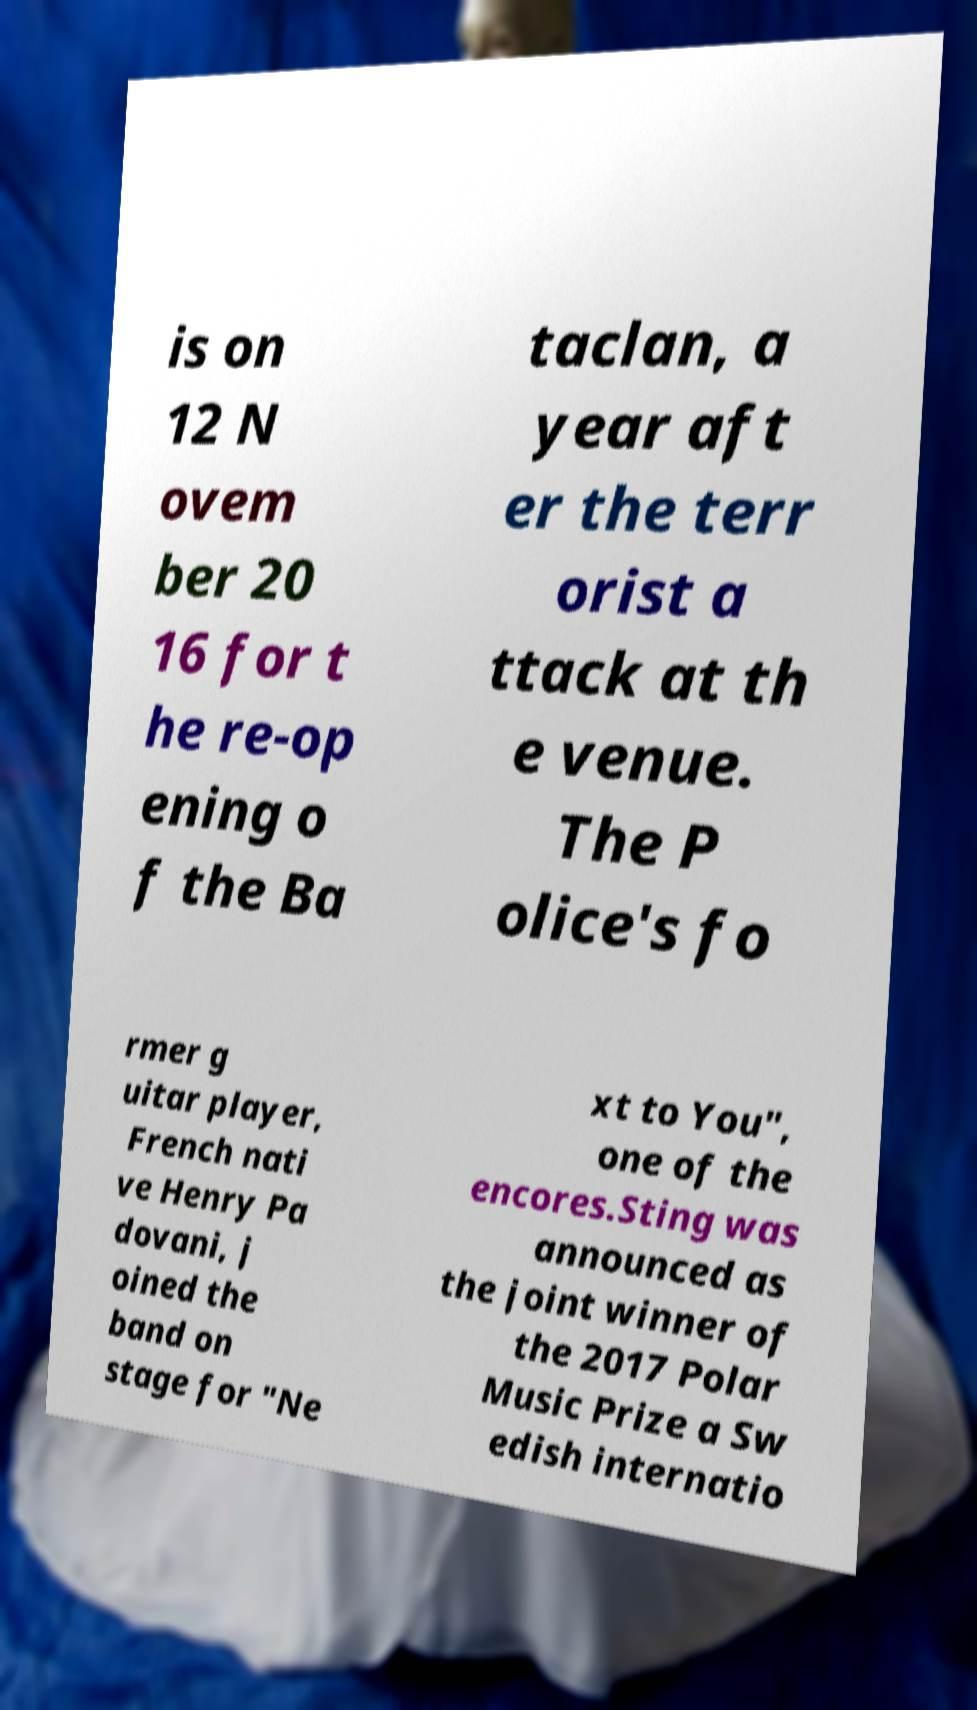Could you assist in decoding the text presented in this image and type it out clearly? is on 12 N ovem ber 20 16 for t he re-op ening o f the Ba taclan, a year aft er the terr orist a ttack at th e venue. The P olice's fo rmer g uitar player, French nati ve Henry Pa dovani, j oined the band on stage for "Ne xt to You", one of the encores.Sting was announced as the joint winner of the 2017 Polar Music Prize a Sw edish internatio 